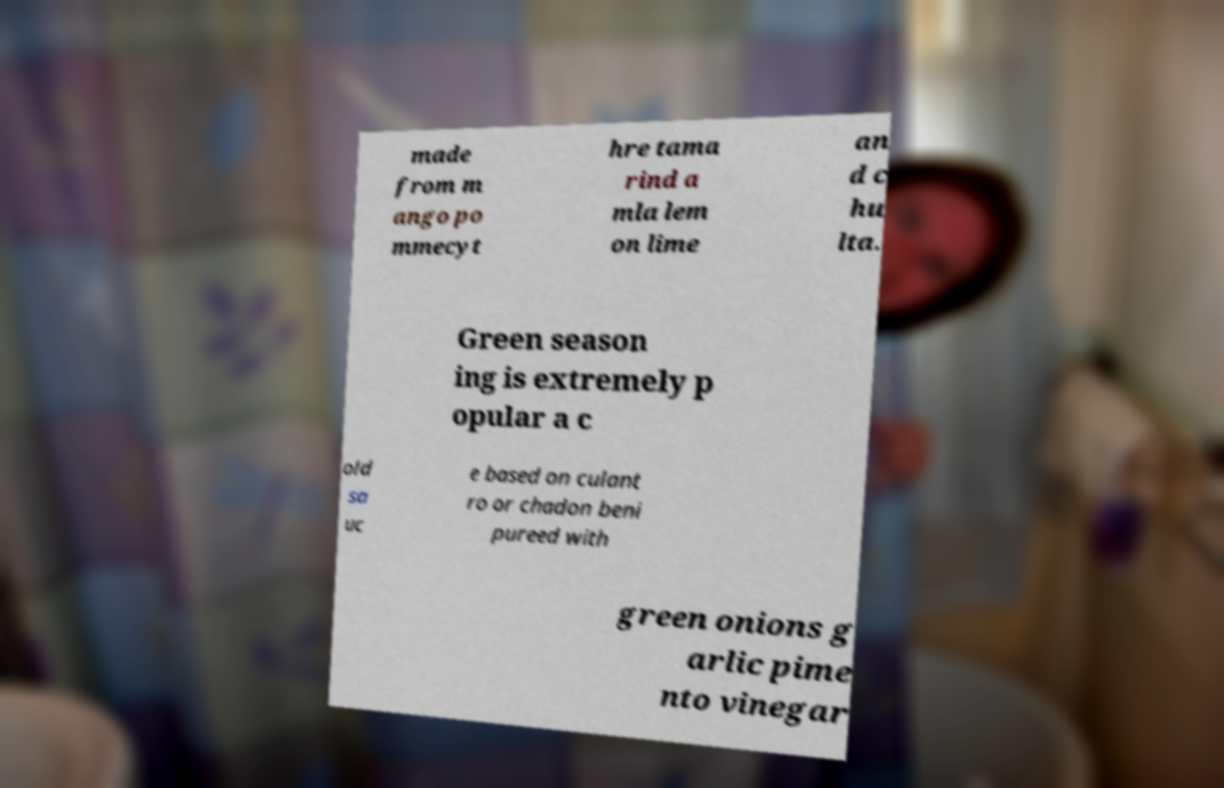What messages or text are displayed in this image? I need them in a readable, typed format. made from m ango po mmecyt hre tama rind a mla lem on lime an d c hu lta. Green season ing is extremely p opular a c old sa uc e based on culant ro or chadon beni pureed with green onions g arlic pime nto vinegar 